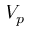Convert formula to latex. <formula><loc_0><loc_0><loc_500><loc_500>V _ { p }</formula> 